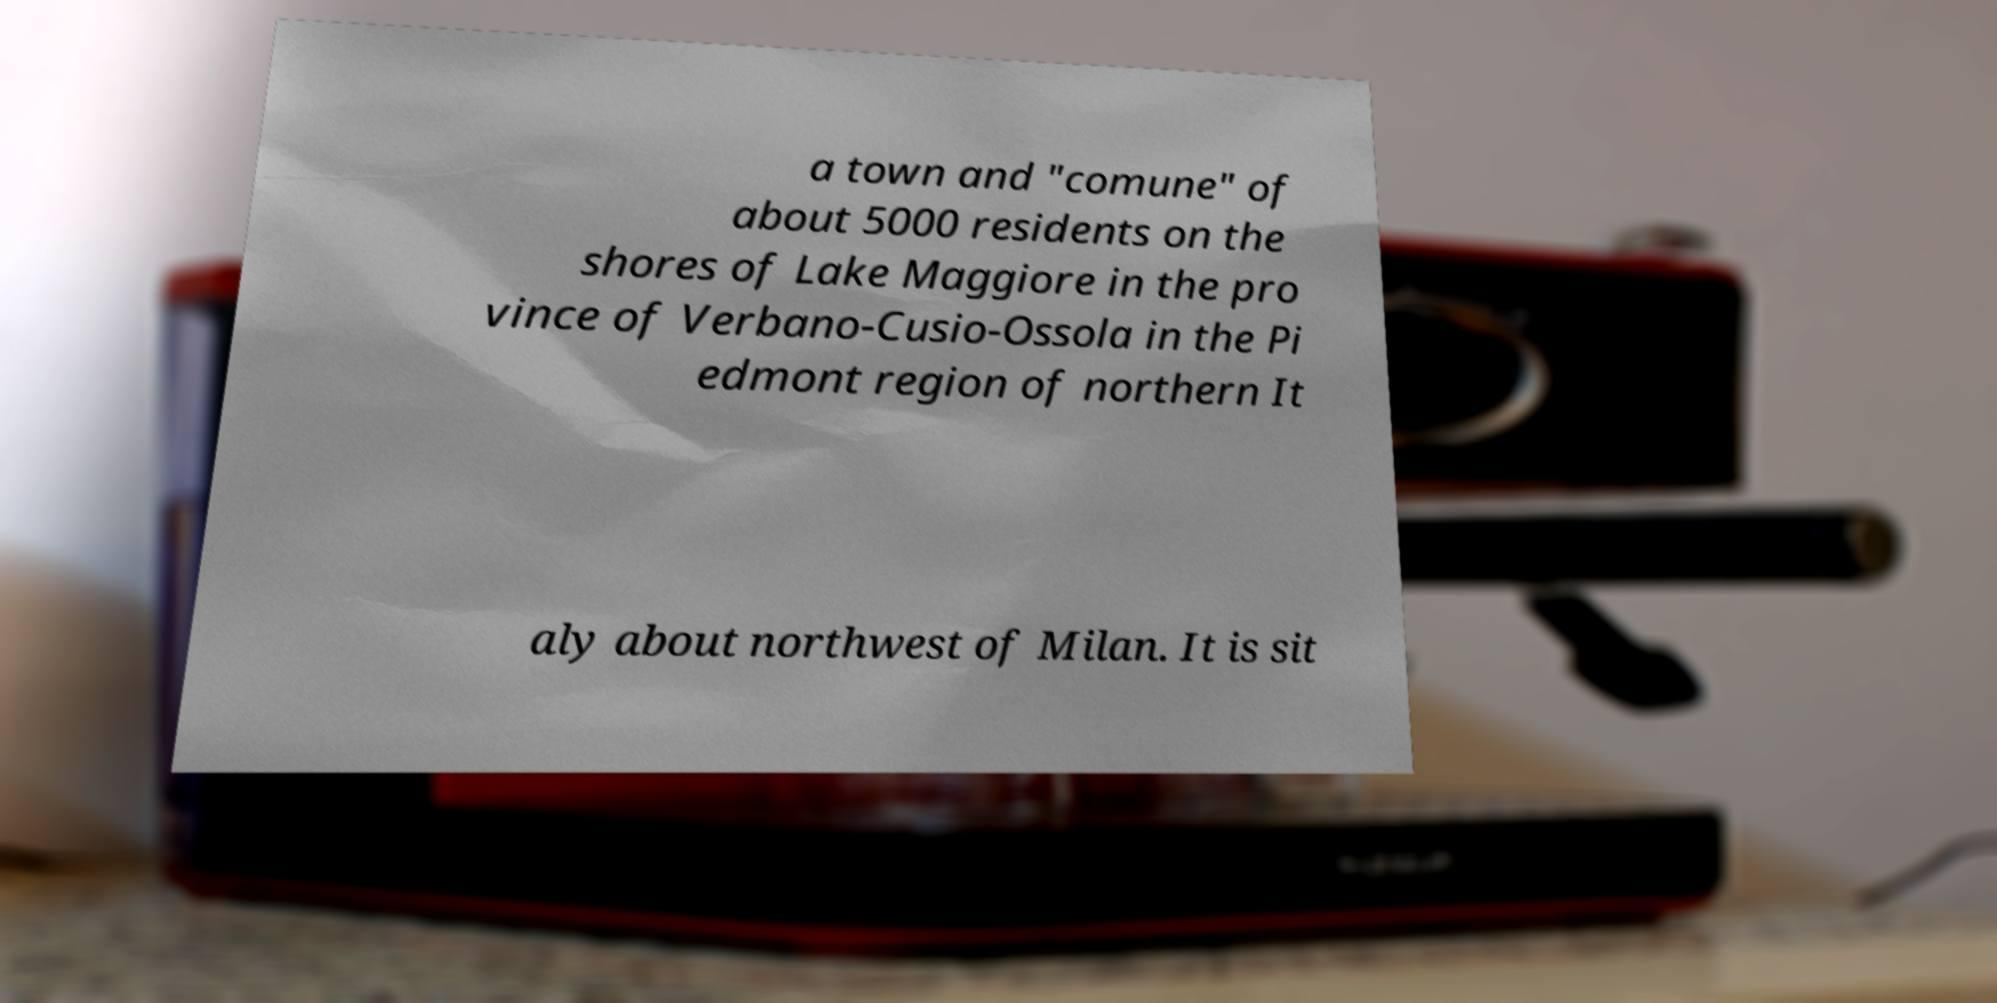I need the written content from this picture converted into text. Can you do that? a town and "comune" of about 5000 residents on the shores of Lake Maggiore in the pro vince of Verbano-Cusio-Ossola in the Pi edmont region of northern It aly about northwest of Milan. It is sit 